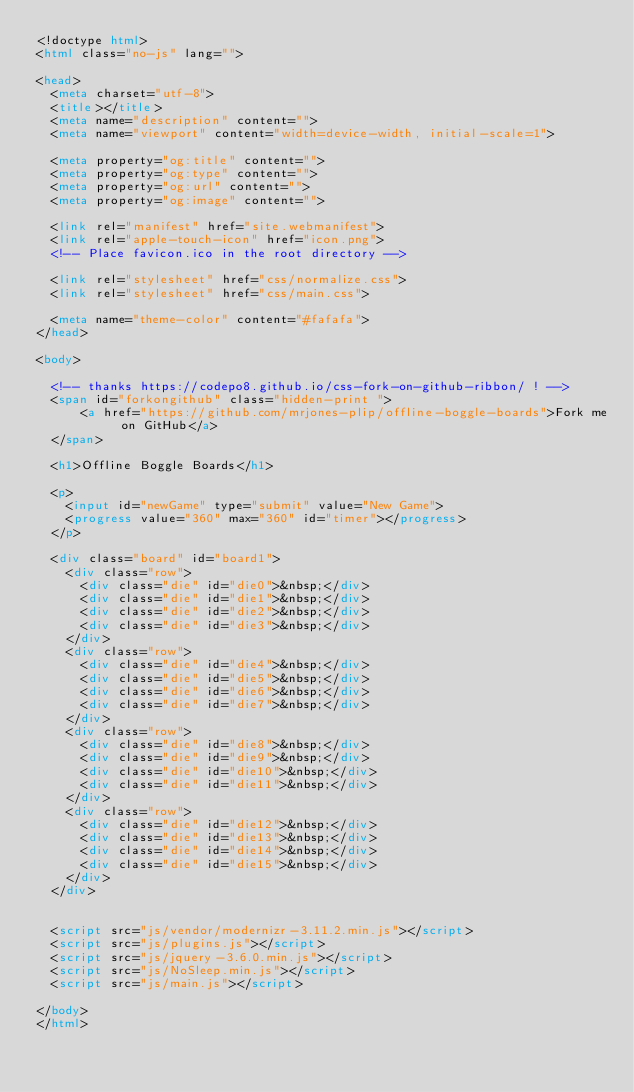<code> <loc_0><loc_0><loc_500><loc_500><_HTML_><!doctype html>
<html class="no-js" lang="">

<head>
  <meta charset="utf-8">
  <title></title>
  <meta name="description" content="">
  <meta name="viewport" content="width=device-width, initial-scale=1">

  <meta property="og:title" content="">
  <meta property="og:type" content="">
  <meta property="og:url" content="">
  <meta property="og:image" content="">

  <link rel="manifest" href="site.webmanifest">
  <link rel="apple-touch-icon" href="icon.png">
  <!-- Place favicon.ico in the root directory -->

  <link rel="stylesheet" href="css/normalize.css">
  <link rel="stylesheet" href="css/main.css">

  <meta name="theme-color" content="#fafafa">
</head>

<body>

  <!-- thanks https://codepo8.github.io/css-fork-on-github-ribbon/ ! -->
  <span id="forkongithub" class="hidden-print ">
      <a href="https://github.com/mrjones-plip/offline-boggle-boards">Fork me on GitHub</a>
  </span>

  <h1>Offline Boggle Boards</h1>

  <p>
    <input id="newGame" type="submit" value="New Game">
    <progress value="360" max="360" id="timer"></progress>
  </p>

  <div class="board" id="board1">
    <div class="row">
      <div class="die" id="die0">&nbsp;</div>
      <div class="die" id="die1">&nbsp;</div>
      <div class="die" id="die2">&nbsp;</div>
      <div class="die" id="die3">&nbsp;</div>
    </div>
    <div class="row">
      <div class="die" id="die4">&nbsp;</div>
      <div class="die" id="die5">&nbsp;</div>
      <div class="die" id="die6">&nbsp;</div>
      <div class="die" id="die7">&nbsp;</div>
    </div>
    <div class="row">
      <div class="die" id="die8">&nbsp;</div>
      <div class="die" id="die9">&nbsp;</div>
      <div class="die" id="die10">&nbsp;</div>
      <div class="die" id="die11">&nbsp;</div>
    </div>
    <div class="row">
      <div class="die" id="die12">&nbsp;</div>
      <div class="die" id="die13">&nbsp;</div>
      <div class="die" id="die14">&nbsp;</div>
      <div class="die" id="die15">&nbsp;</div>
    </div>
  </div>


  <script src="js/vendor/modernizr-3.11.2.min.js"></script>
  <script src="js/plugins.js"></script>
  <script src="js/jquery-3.6.0.min.js"></script>
  <script src="js/NoSleep.min.js"></script>
  <script src="js/main.js"></script>

</body>
</html>
</code> 